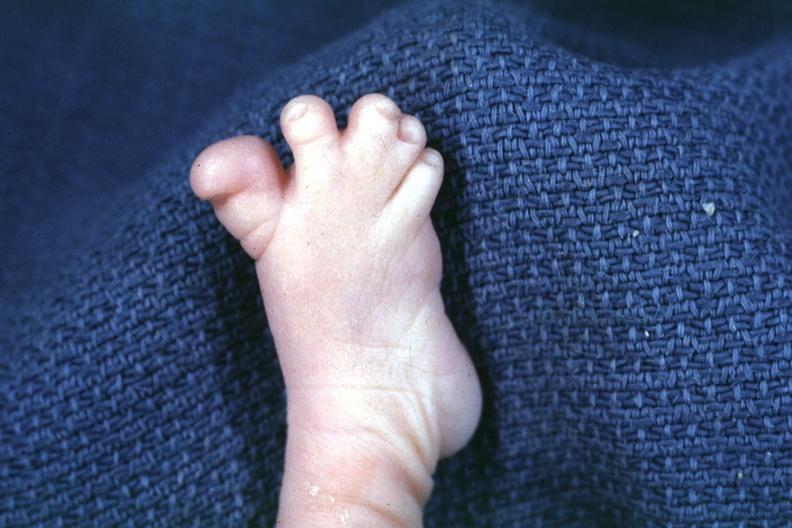s palmar crease normal present?
Answer the question using a single word or phrase. No 